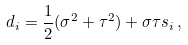<formula> <loc_0><loc_0><loc_500><loc_500>d _ { i } = \frac { 1 } { 2 } ( \sigma ^ { 2 } + \tau ^ { 2 } ) + \sigma \tau s _ { i } \, ,</formula> 